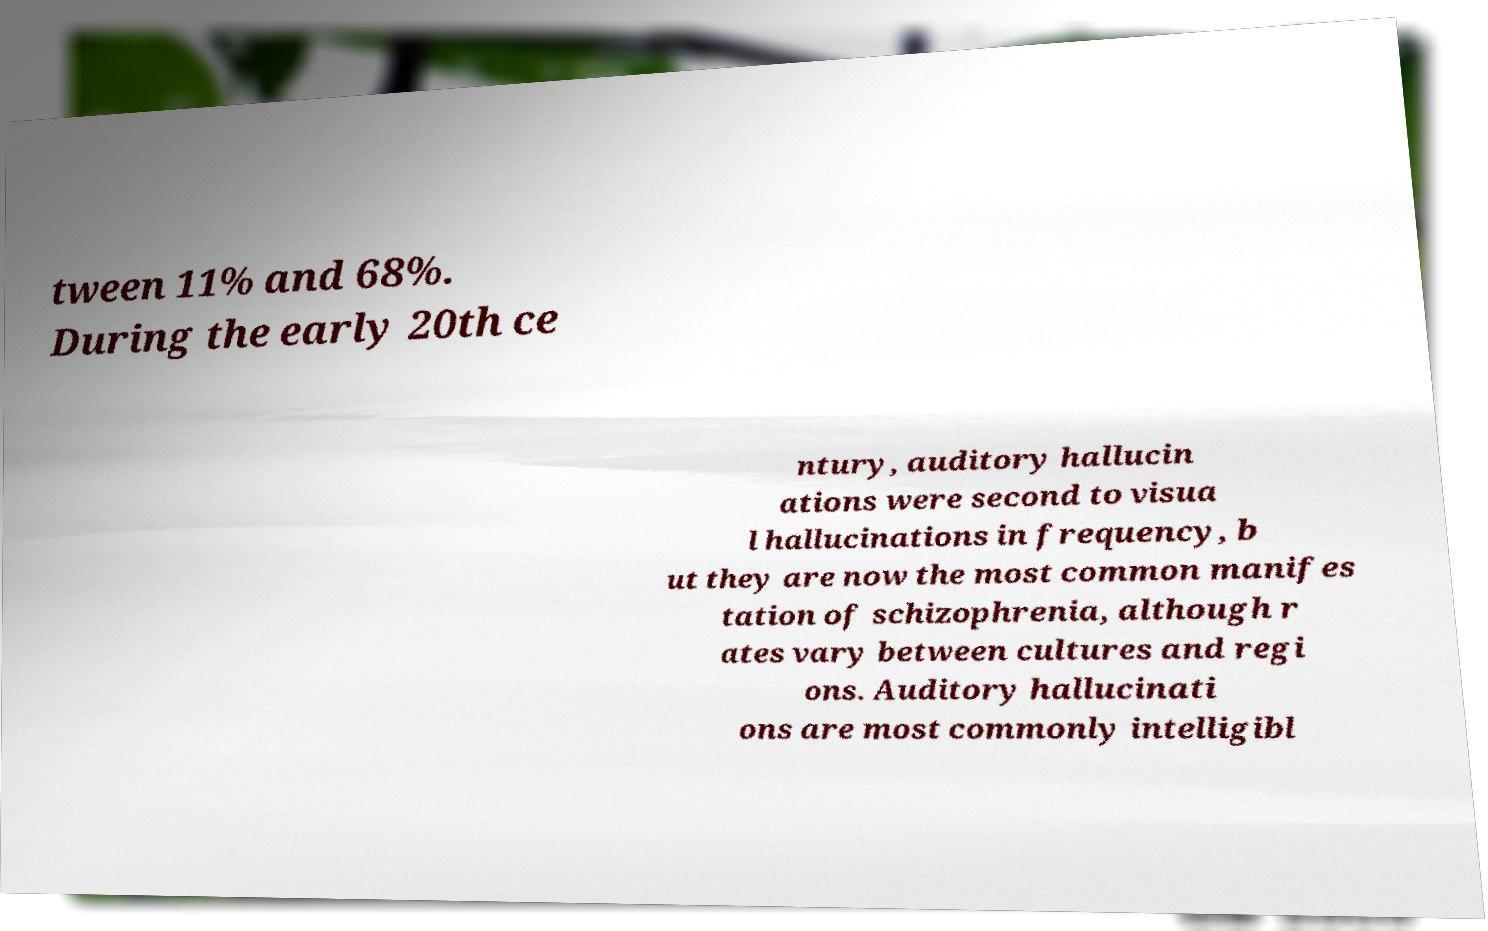What messages or text are displayed in this image? I need them in a readable, typed format. tween 11% and 68%. During the early 20th ce ntury, auditory hallucin ations were second to visua l hallucinations in frequency, b ut they are now the most common manifes tation of schizophrenia, although r ates vary between cultures and regi ons. Auditory hallucinati ons are most commonly intelligibl 